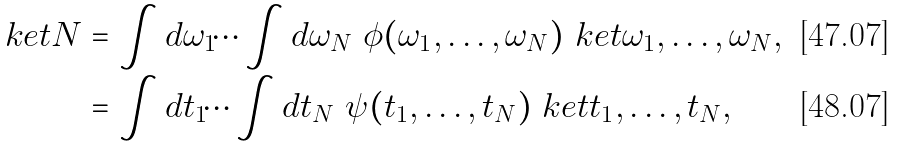Convert formula to latex. <formula><loc_0><loc_0><loc_500><loc_500>\ k e t { N } & = \int d \omega _ { 1 } \dots \int d \omega _ { N } \ \phi ( \omega _ { 1 } , \dots , \omega _ { N } ) \ k e t { \omega _ { 1 } , \dots , \omega _ { N } } , \\ & = \int d t _ { 1 } \dots \int d t _ { N } \ \psi ( t _ { 1 } , \dots , t _ { N } ) \ k e t { t _ { 1 } , \dots , t _ { N } } ,</formula> 